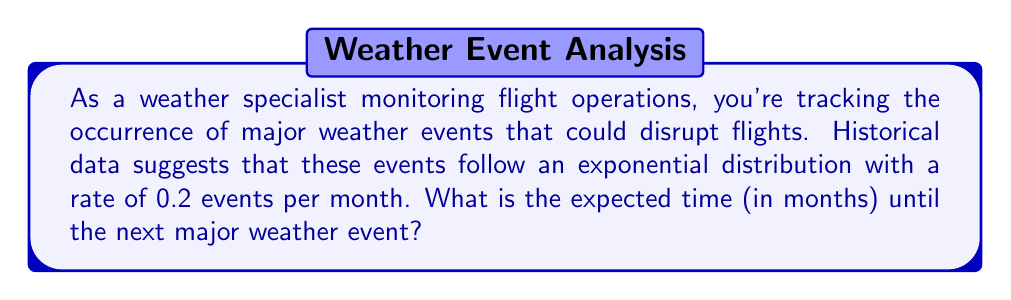Provide a solution to this math problem. To solve this problem, we need to use the properties of the exponential distribution:

1) The exponential distribution is often used to model the time between events in a Poisson process, which is appropriate for random events occurring at a constant average rate.

2) For an exponential distribution with rate parameter $\lambda$, the expected value (mean) is given by:

   $$E[X] = \frac{1}{\lambda}$$

3) In this case, we're given that $\lambda = 0.2$ events per month.

4) Substituting this into our formula:

   $$E[X] = \frac{1}{0.2} = 5$$

Therefore, the expected time until the next major weather event is 5 months.

This means that, on average, we would expect a major weather event to occur every 5 months. However, it's important to note that due to the memoryless property of the exponential distribution, this expected time remains the same regardless of how long it has been since the last event.
Answer: The expected time until the next major weather event is 5 months. 